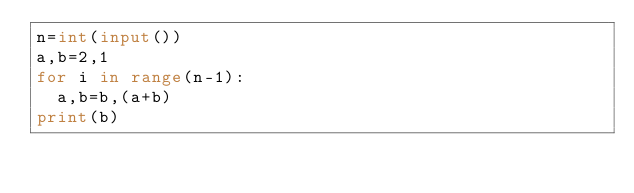<code> <loc_0><loc_0><loc_500><loc_500><_Python_>n=int(input())
a,b=2,1
for i in range(n-1):
  a,b=b,(a+b)
print(b)</code> 